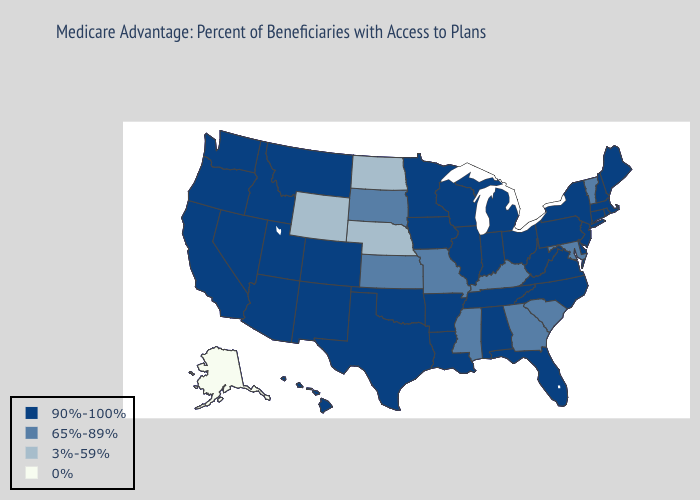Among the states that border Arkansas , which have the highest value?
Be succinct. Louisiana, Oklahoma, Tennessee, Texas. Does Montana have a lower value than Nevada?
Answer briefly. No. Which states hav the highest value in the Northeast?
Short answer required. Connecticut, Massachusetts, Maine, New Hampshire, New Jersey, New York, Pennsylvania, Rhode Island. What is the highest value in states that border New Jersey?
Concise answer only. 90%-100%. What is the lowest value in states that border Maine?
Quick response, please. 90%-100%. What is the highest value in the Northeast ?
Concise answer only. 90%-100%. What is the value of Massachusetts?
Quick response, please. 90%-100%. Name the states that have a value in the range 65%-89%?
Quick response, please. Georgia, Kansas, Kentucky, Maryland, Missouri, Mississippi, South Carolina, South Dakota, Vermont. Does Mississippi have the lowest value in the USA?
Concise answer only. No. Does New York have the same value as Pennsylvania?
Concise answer only. Yes. What is the highest value in the USA?
Write a very short answer. 90%-100%. Among the states that border Washington , which have the lowest value?
Give a very brief answer. Idaho, Oregon. Name the states that have a value in the range 0%?
Give a very brief answer. Alaska. Does the map have missing data?
Concise answer only. No. Among the states that border Delaware , does New Jersey have the lowest value?
Keep it brief. No. 